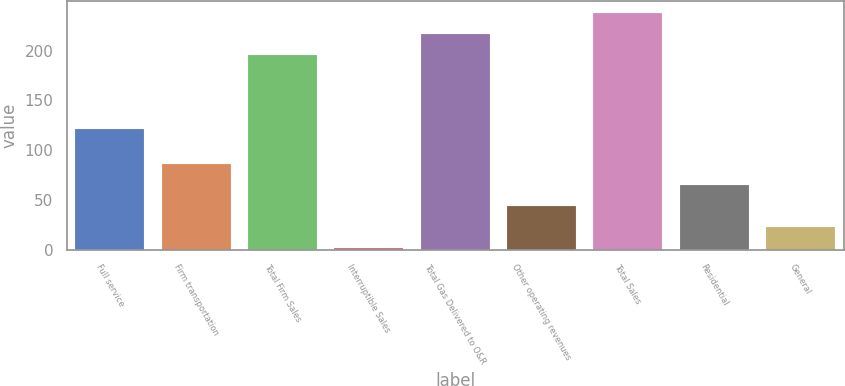<chart> <loc_0><loc_0><loc_500><loc_500><bar_chart><fcel>Full service<fcel>Firm transportation<fcel>Total Firm Sales<fcel>Interruptible Sales<fcel>Total Gas Delivered to O&R<fcel>Other operating revenues<fcel>Total Sales<fcel>Residential<fcel>General<nl><fcel>121<fcel>86<fcel>196<fcel>2<fcel>217<fcel>44<fcel>238<fcel>65<fcel>23<nl></chart> 